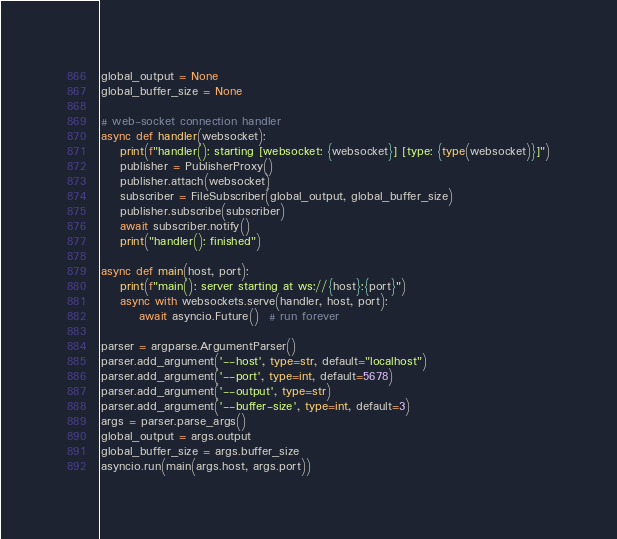Convert code to text. <code><loc_0><loc_0><loc_500><loc_500><_Python_>global_output = None
global_buffer_size = None

# web-socket connection handler
async def handler(websocket):
    print(f"handler(): starting [websocket: {websocket}] [type: {type(websocket)}]")
    publisher = PublisherProxy()
    publisher.attach(websocket)
    subscriber = FileSubscriber(global_output, global_buffer_size)
    publisher.subscribe(subscriber)
    await subscriber.notify()
    print("handler(): finished")

async def main(host, port):
    print(f"main(): server starting at ws://{host}:{port}")
    async with websockets.serve(handler, host, port):
        await asyncio.Future()  # run forever

parser = argparse.ArgumentParser()
parser.add_argument('--host', type=str, default="localhost")
parser.add_argument('--port', type=int, default=5678)
parser.add_argument('--output', type=str)
parser.add_argument('--buffer-size', type=int, default=3)
args = parser.parse_args()
global_output = args.output
global_buffer_size = args.buffer_size
asyncio.run(main(args.host, args.port))
</code> 